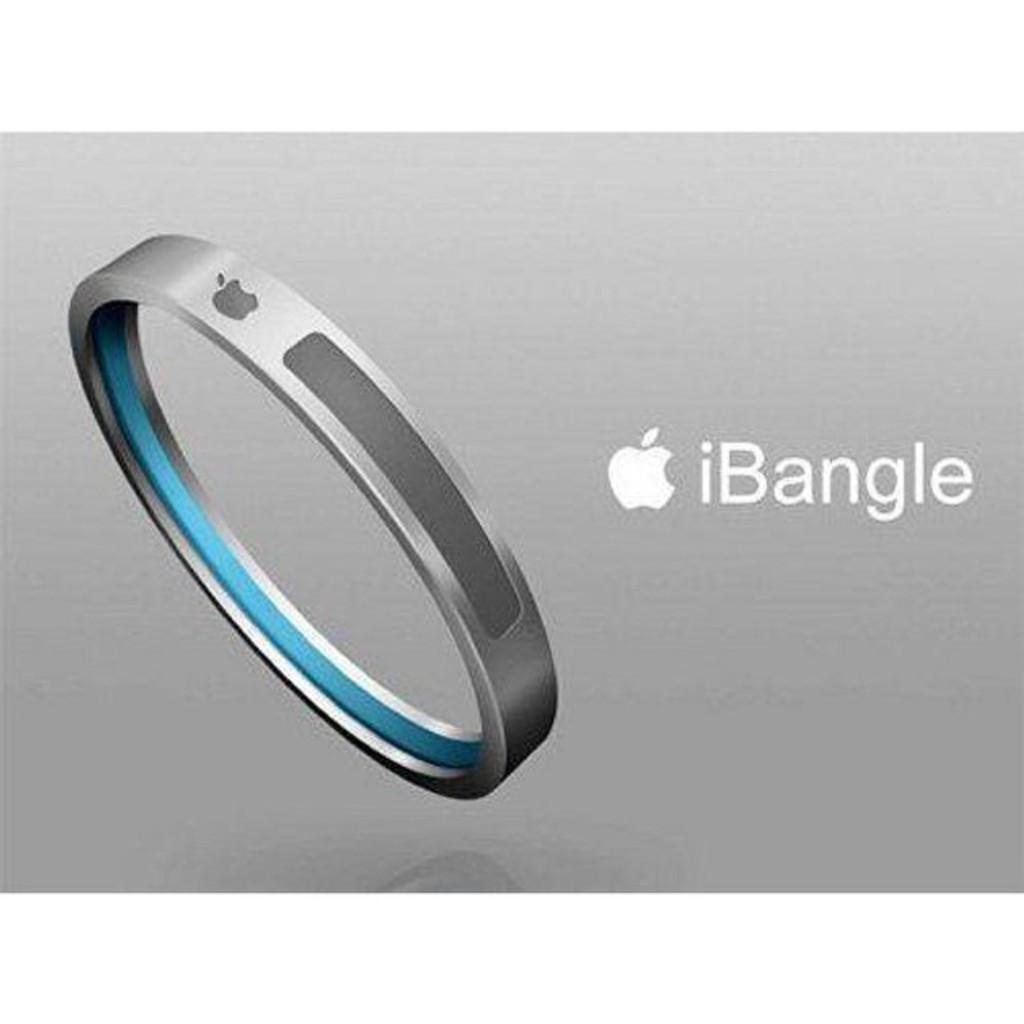<image>
Describe the image concisely. The iBangle has the Apple logo on the front of the bracelet. 